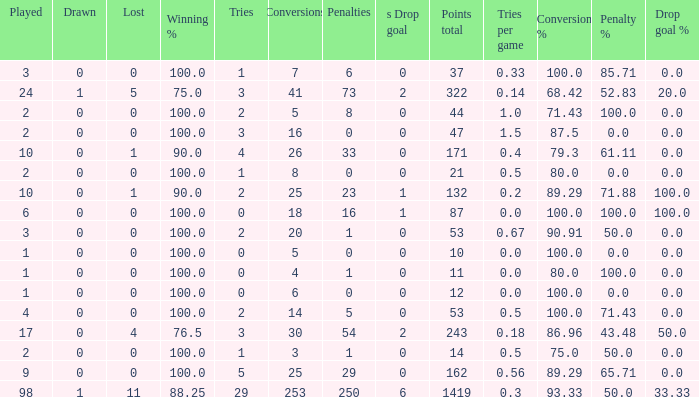Can you give me this table as a dict? {'header': ['Played', 'Drawn', 'Lost', 'Winning %', 'Tries', 'Conversions', 'Penalties', 's Drop goal', 'Points total', 'Tries per game', 'Conversion %', 'Penalty %', 'Drop goal %'], 'rows': [['3', '0', '0', '100.0', '1', '7', '6', '0', '37', '0.33', '100.0', '85.71', '0.0'], ['24', '1', '5', '75.0', '3', '41', '73', '2', '322', '0.14', '68.42', '52.83', '20.0'], ['2', '0', '0', '100.0', '2', '5', '8', '0', '44', '1.0', '71.43', '100.0', '0.0'], ['2', '0', '0', '100.0', '3', '16', '0', '0', '47', '1.5', '87.5', '0.0', '0.0'], ['10', '0', '1', '90.0', '4', '26', '33', '0', '171', '0.4', '79.3', '61.11', '0.0'], ['2', '0', '0', '100.0', '1', '8', '0', '0', '21', '0.5', '80.0', '0.0', '0.0'], ['10', '0', '1', '90.0', '2', '25', '23', '1', '132', '0.2', '89.29', '71.88', '100.0'], ['6', '0', '0', '100.0', '0', '18', '16', '1', '87', '0.0', '100.0', '100.0', '100.0'], ['3', '0', '0', '100.0', '2', '20', '1', '0', '53', '0.67', '90.91', '50.0', '0.0'], ['1', '0', '0', '100.0', '0', '5', '0', '0', '10', '0.0', '100.0', '0.0', '0.0'], ['1', '0', '0', '100.0', '0', '4', '1', '0', '11', '0.0', '80.0', '100.0', '0.0'], ['1', '0', '0', '100.0', '0', '6', '0', '0', '12', '0.0', '100.0', '0.0', '0.0'], ['4', '0', '0', '100.0', '2', '14', '5', '0', '53', '0.5', '100.0', '71.43', '0.0'], ['17', '0', '4', '76.5', '3', '30', '54', '2', '243', '0.18', '86.96', '43.48', '50.0'], ['2', '0', '0', '100.0', '1', '3', '1', '0', '14', '0.5', '75.0', '50.0', '0.0'], ['9', '0', '0', '100.0', '5', '25', '29', '0', '162', '0.56', '89.29', '65.71', '0.0'], ['98', '1', '11', '88.25', '29', '253', '250', '6', '1419', '0.3', '93.33', '50.0', '33.33']]} How many ties did he have when he had 1 penalties and more than 20 conversions? None. 